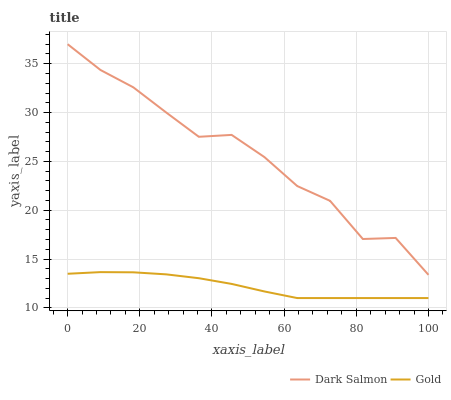Does Gold have the maximum area under the curve?
Answer yes or no. No. Is Gold the roughest?
Answer yes or no. No. Does Gold have the highest value?
Answer yes or no. No. Is Gold less than Dark Salmon?
Answer yes or no. Yes. Is Dark Salmon greater than Gold?
Answer yes or no. Yes. Does Gold intersect Dark Salmon?
Answer yes or no. No. 